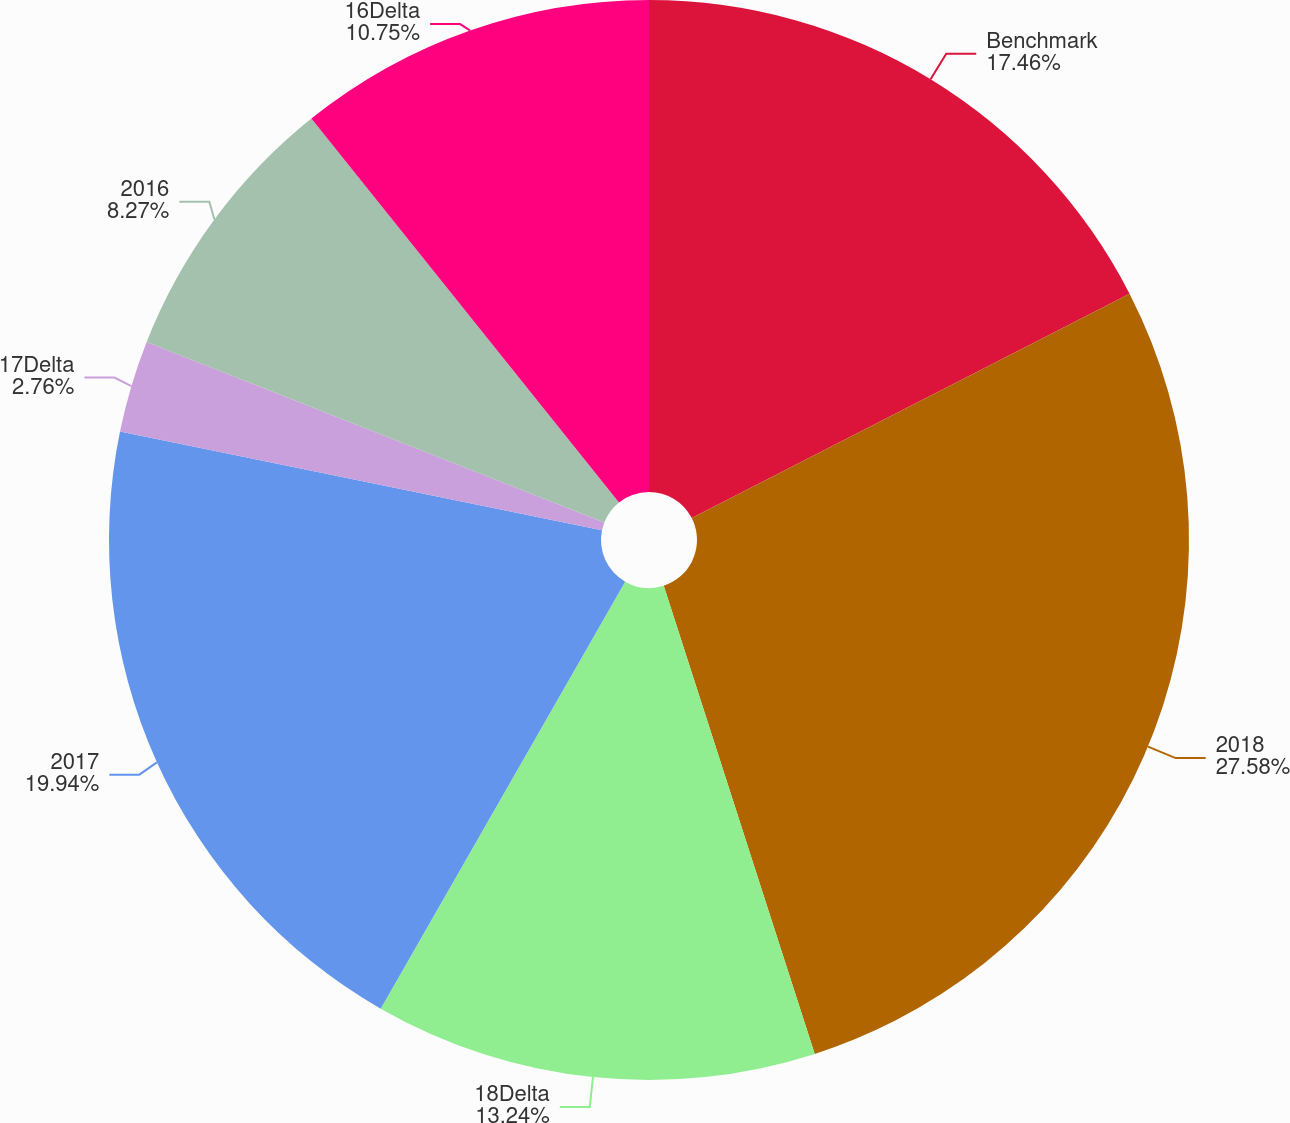<chart> <loc_0><loc_0><loc_500><loc_500><pie_chart><fcel>Benchmark<fcel>2018<fcel>18Delta<fcel>2017<fcel>17Delta<fcel>2016<fcel>16Delta<nl><fcel>17.46%<fcel>27.57%<fcel>13.24%<fcel>19.94%<fcel>2.76%<fcel>8.27%<fcel>10.75%<nl></chart> 